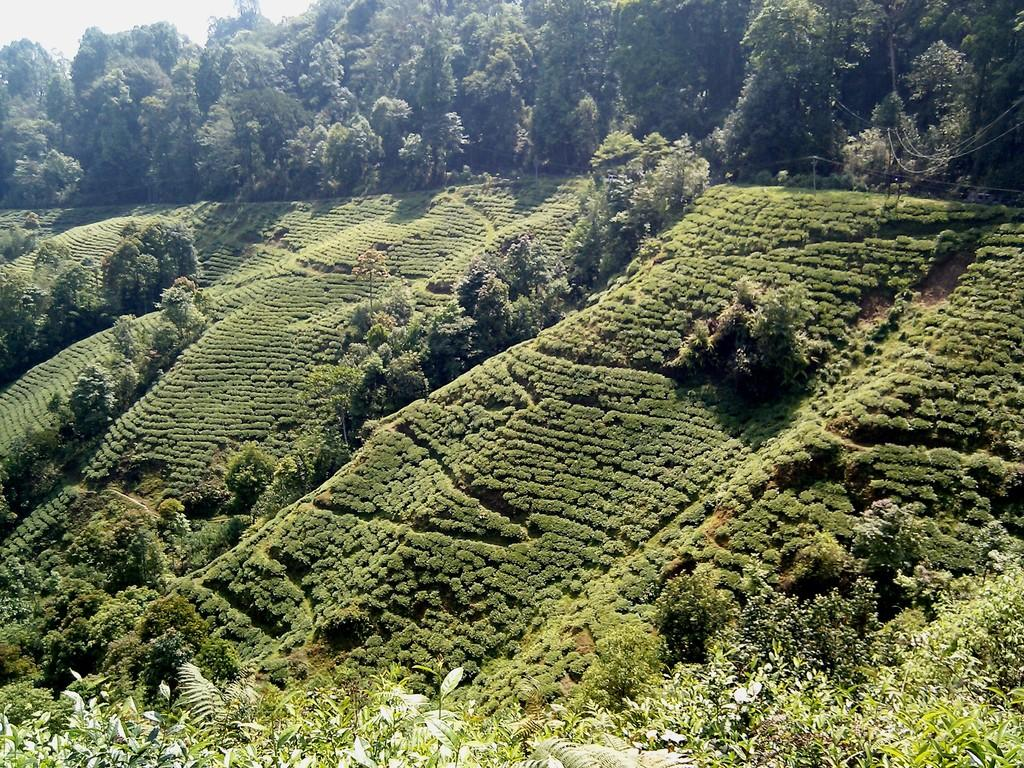What type of natural environment is visible in the image? There is greenery visible in the image. Can you tell me how many wishes are granted to the cheese in the image? There is no cheese present in the image, and therefore no wishes can be granted to it. 